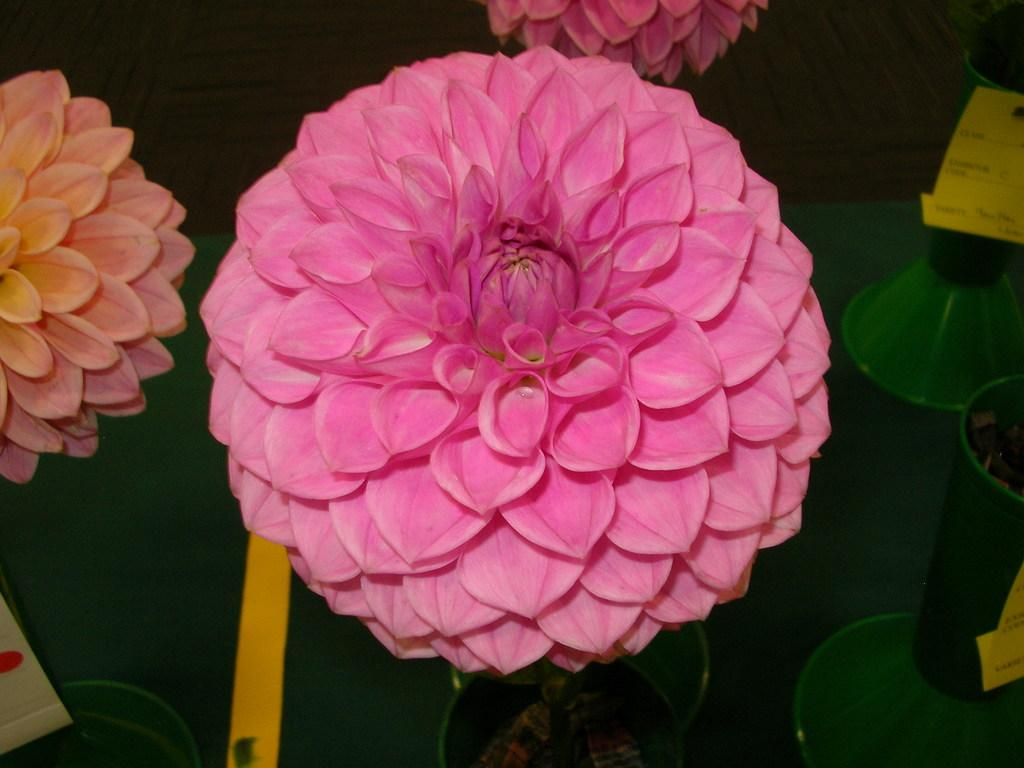What is the main subject of the image? The main subject of the image is a pink flower. Where is the pink flower located in the image? The pink flower is in the middle of the image. What can be observed about the background of the image? The background of the image is dark. How many divisions can be seen in the root of the pink flower in the image? There is no root visible in the image, as it only shows a pink flower. 